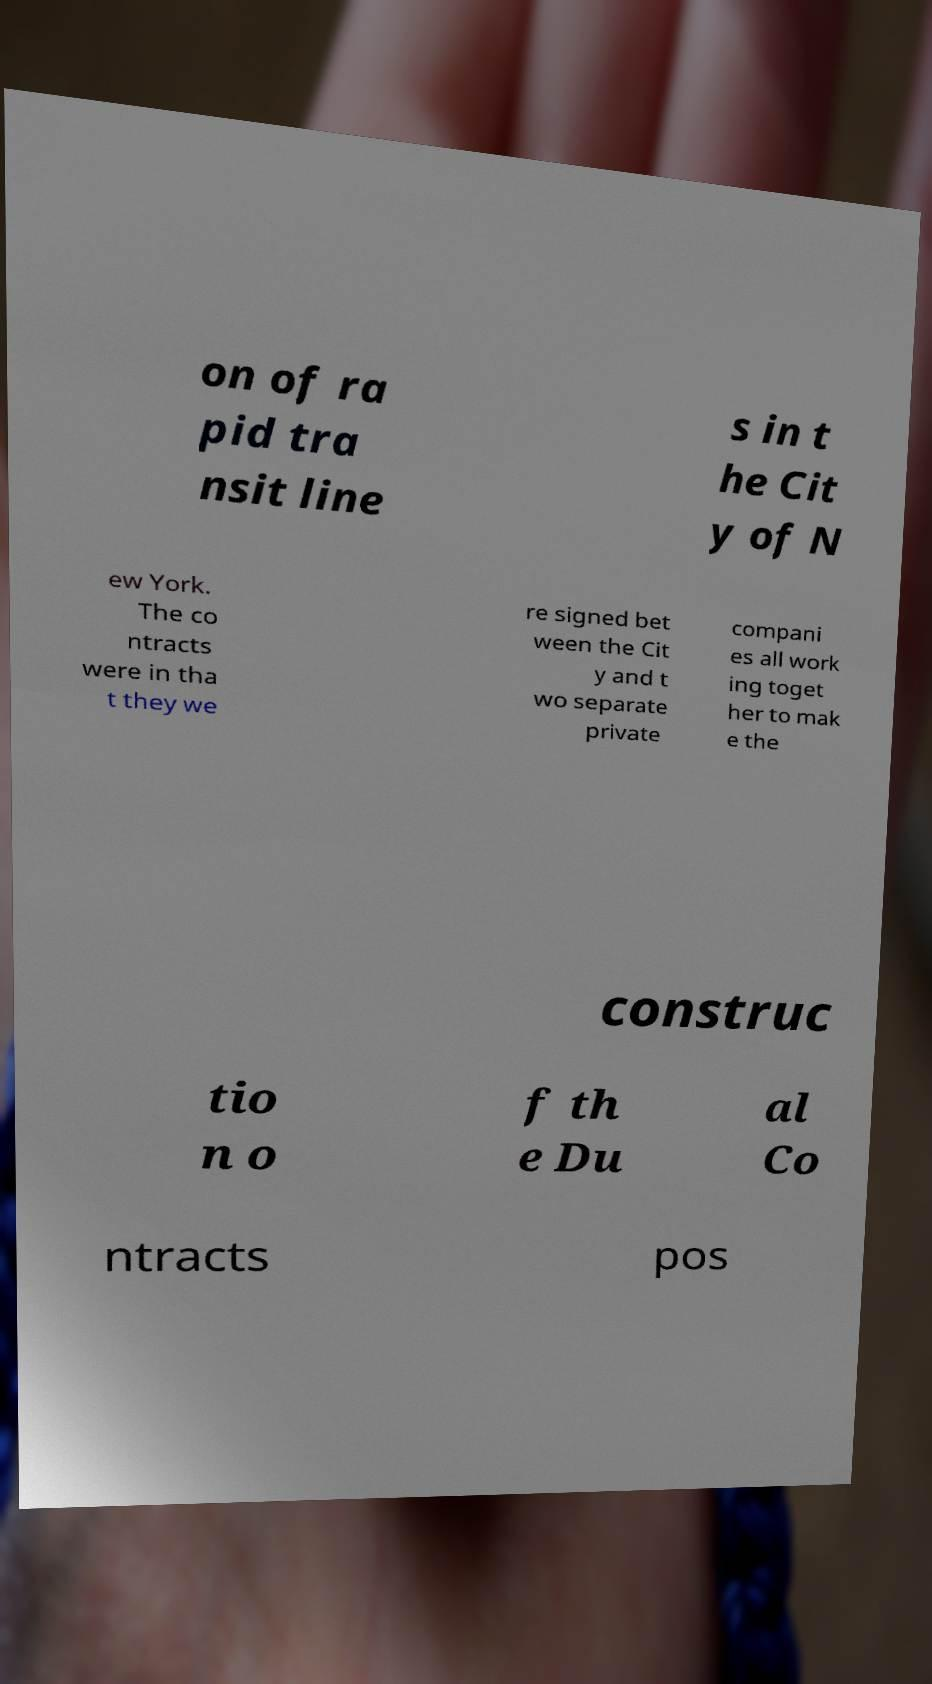Can you read and provide the text displayed in the image?This photo seems to have some interesting text. Can you extract and type it out for me? on of ra pid tra nsit line s in t he Cit y of N ew York. The co ntracts were in tha t they we re signed bet ween the Cit y and t wo separate private compani es all work ing toget her to mak e the construc tio n o f th e Du al Co ntracts pos 